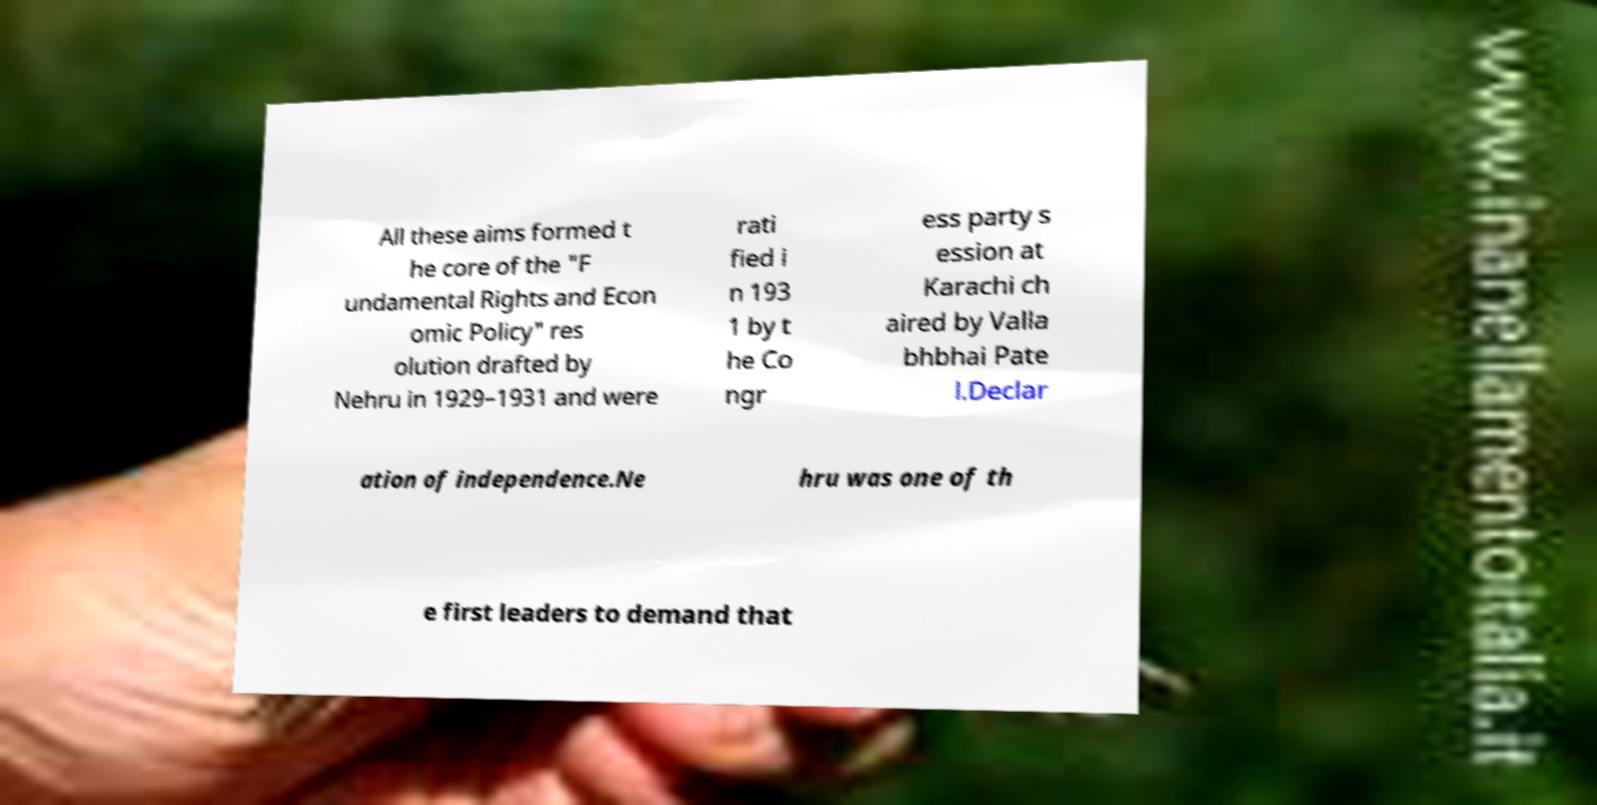I need the written content from this picture converted into text. Can you do that? All these aims formed t he core of the "F undamental Rights and Econ omic Policy" res olution drafted by Nehru in 1929–1931 and were rati fied i n 193 1 by t he Co ngr ess party s ession at Karachi ch aired by Valla bhbhai Pate l.Declar ation of independence.Ne hru was one of th e first leaders to demand that 